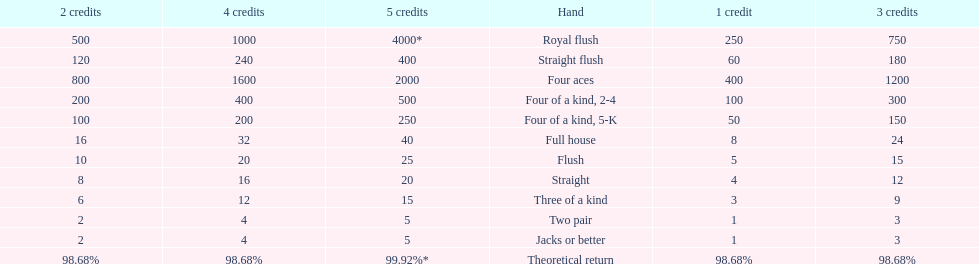At most, what could a person earn for having a full house? 40. 